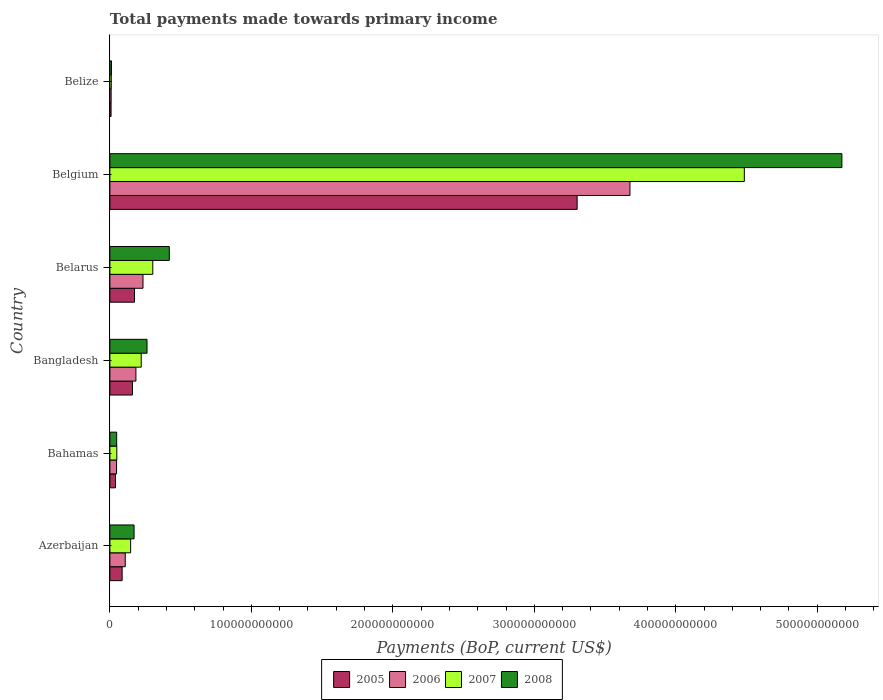Are the number of bars per tick equal to the number of legend labels?
Make the answer very short. Yes. Are the number of bars on each tick of the Y-axis equal?
Provide a succinct answer. Yes. What is the label of the 1st group of bars from the top?
Give a very brief answer. Belize. What is the total payments made towards primary income in 2008 in Belgium?
Your answer should be compact. 5.17e+11. Across all countries, what is the maximum total payments made towards primary income in 2005?
Provide a succinct answer. 3.30e+11. Across all countries, what is the minimum total payments made towards primary income in 2006?
Your response must be concise. 8.85e+08. In which country was the total payments made towards primary income in 2008 minimum?
Make the answer very short. Belize. What is the total total payments made towards primary income in 2005 in the graph?
Keep it short and to the point. 3.77e+11. What is the difference between the total payments made towards primary income in 2006 in Belarus and that in Belgium?
Offer a terse response. -3.44e+11. What is the difference between the total payments made towards primary income in 2008 in Belize and the total payments made towards primary income in 2007 in Belgium?
Give a very brief answer. -4.47e+11. What is the average total payments made towards primary income in 2008 per country?
Your answer should be compact. 1.01e+11. What is the difference between the total payments made towards primary income in 2006 and total payments made towards primary income in 2005 in Bahamas?
Give a very brief answer. 7.72e+08. In how many countries, is the total payments made towards primary income in 2008 greater than 280000000000 US$?
Your response must be concise. 1. What is the ratio of the total payments made towards primary income in 2005 in Azerbaijan to that in Belarus?
Offer a terse response. 0.5. What is the difference between the highest and the second highest total payments made towards primary income in 2007?
Offer a very short reply. 4.18e+11. What is the difference between the highest and the lowest total payments made towards primary income in 2008?
Give a very brief answer. 5.16e+11. In how many countries, is the total payments made towards primary income in 2008 greater than the average total payments made towards primary income in 2008 taken over all countries?
Keep it short and to the point. 1. Is it the case that in every country, the sum of the total payments made towards primary income in 2007 and total payments made towards primary income in 2005 is greater than the sum of total payments made towards primary income in 2008 and total payments made towards primary income in 2006?
Ensure brevity in your answer.  No. What does the 4th bar from the top in Belize represents?
Ensure brevity in your answer.  2005. What does the 4th bar from the bottom in Belarus represents?
Your answer should be compact. 2008. What is the difference between two consecutive major ticks on the X-axis?
Give a very brief answer. 1.00e+11. How are the legend labels stacked?
Offer a terse response. Horizontal. What is the title of the graph?
Your response must be concise. Total payments made towards primary income. Does "2004" appear as one of the legend labels in the graph?
Your response must be concise. No. What is the label or title of the X-axis?
Give a very brief answer. Payments (BoP, current US$). What is the label or title of the Y-axis?
Provide a short and direct response. Country. What is the Payments (BoP, current US$) in 2005 in Azerbaijan?
Offer a terse response. 8.66e+09. What is the Payments (BoP, current US$) in 2006 in Azerbaijan?
Provide a short and direct response. 1.09e+1. What is the Payments (BoP, current US$) of 2007 in Azerbaijan?
Keep it short and to the point. 1.47e+1. What is the Payments (BoP, current US$) in 2008 in Azerbaijan?
Give a very brief answer. 1.71e+1. What is the Payments (BoP, current US$) in 2005 in Bahamas?
Make the answer very short. 3.94e+09. What is the Payments (BoP, current US$) of 2006 in Bahamas?
Your answer should be compact. 4.71e+09. What is the Payments (BoP, current US$) in 2007 in Bahamas?
Offer a very short reply. 4.89e+09. What is the Payments (BoP, current US$) in 2008 in Bahamas?
Make the answer very short. 4.80e+09. What is the Payments (BoP, current US$) of 2005 in Bangladesh?
Ensure brevity in your answer.  1.60e+1. What is the Payments (BoP, current US$) in 2006 in Bangladesh?
Ensure brevity in your answer.  1.84e+1. What is the Payments (BoP, current US$) of 2007 in Bangladesh?
Ensure brevity in your answer.  2.22e+1. What is the Payments (BoP, current US$) of 2008 in Bangladesh?
Provide a succinct answer. 2.62e+1. What is the Payments (BoP, current US$) in 2005 in Belarus?
Provide a short and direct response. 1.74e+1. What is the Payments (BoP, current US$) of 2006 in Belarus?
Your response must be concise. 2.34e+1. What is the Payments (BoP, current US$) of 2007 in Belarus?
Give a very brief answer. 3.03e+1. What is the Payments (BoP, current US$) in 2008 in Belarus?
Your answer should be compact. 4.20e+1. What is the Payments (BoP, current US$) in 2005 in Belgium?
Your answer should be compact. 3.30e+11. What is the Payments (BoP, current US$) in 2006 in Belgium?
Provide a short and direct response. 3.68e+11. What is the Payments (BoP, current US$) in 2007 in Belgium?
Your answer should be compact. 4.48e+11. What is the Payments (BoP, current US$) of 2008 in Belgium?
Provide a succinct answer. 5.17e+11. What is the Payments (BoP, current US$) of 2005 in Belize?
Give a very brief answer. 8.24e+08. What is the Payments (BoP, current US$) of 2006 in Belize?
Offer a very short reply. 8.85e+08. What is the Payments (BoP, current US$) in 2007 in Belize?
Your answer should be compact. 9.69e+08. What is the Payments (BoP, current US$) of 2008 in Belize?
Provide a short and direct response. 1.13e+09. Across all countries, what is the maximum Payments (BoP, current US$) of 2005?
Your answer should be compact. 3.30e+11. Across all countries, what is the maximum Payments (BoP, current US$) in 2006?
Ensure brevity in your answer.  3.68e+11. Across all countries, what is the maximum Payments (BoP, current US$) in 2007?
Make the answer very short. 4.48e+11. Across all countries, what is the maximum Payments (BoP, current US$) of 2008?
Your response must be concise. 5.17e+11. Across all countries, what is the minimum Payments (BoP, current US$) of 2005?
Your response must be concise. 8.24e+08. Across all countries, what is the minimum Payments (BoP, current US$) of 2006?
Ensure brevity in your answer.  8.85e+08. Across all countries, what is the minimum Payments (BoP, current US$) of 2007?
Provide a succinct answer. 9.69e+08. Across all countries, what is the minimum Payments (BoP, current US$) in 2008?
Provide a succinct answer. 1.13e+09. What is the total Payments (BoP, current US$) in 2005 in the graph?
Provide a succinct answer. 3.77e+11. What is the total Payments (BoP, current US$) in 2006 in the graph?
Your response must be concise. 4.26e+11. What is the total Payments (BoP, current US$) of 2007 in the graph?
Your answer should be very brief. 5.21e+11. What is the total Payments (BoP, current US$) of 2008 in the graph?
Ensure brevity in your answer.  6.09e+11. What is the difference between the Payments (BoP, current US$) in 2005 in Azerbaijan and that in Bahamas?
Keep it short and to the point. 4.71e+09. What is the difference between the Payments (BoP, current US$) of 2006 in Azerbaijan and that in Bahamas?
Offer a very short reply. 6.14e+09. What is the difference between the Payments (BoP, current US$) in 2007 in Azerbaijan and that in Bahamas?
Make the answer very short. 9.78e+09. What is the difference between the Payments (BoP, current US$) in 2008 in Azerbaijan and that in Bahamas?
Provide a short and direct response. 1.23e+1. What is the difference between the Payments (BoP, current US$) in 2005 in Azerbaijan and that in Bangladesh?
Offer a terse response. -7.31e+09. What is the difference between the Payments (BoP, current US$) of 2006 in Azerbaijan and that in Bangladesh?
Your response must be concise. -7.55e+09. What is the difference between the Payments (BoP, current US$) of 2007 in Azerbaijan and that in Bangladesh?
Give a very brief answer. -7.48e+09. What is the difference between the Payments (BoP, current US$) in 2008 in Azerbaijan and that in Bangladesh?
Keep it short and to the point. -9.17e+09. What is the difference between the Payments (BoP, current US$) in 2005 in Azerbaijan and that in Belarus?
Provide a succinct answer. -8.75e+09. What is the difference between the Payments (BoP, current US$) of 2006 in Azerbaijan and that in Belarus?
Keep it short and to the point. -1.26e+1. What is the difference between the Payments (BoP, current US$) of 2007 in Azerbaijan and that in Belarus?
Offer a very short reply. -1.57e+1. What is the difference between the Payments (BoP, current US$) of 2008 in Azerbaijan and that in Belarus?
Keep it short and to the point. -2.49e+1. What is the difference between the Payments (BoP, current US$) in 2005 in Azerbaijan and that in Belgium?
Make the answer very short. -3.22e+11. What is the difference between the Payments (BoP, current US$) of 2006 in Azerbaijan and that in Belgium?
Ensure brevity in your answer.  -3.57e+11. What is the difference between the Payments (BoP, current US$) of 2007 in Azerbaijan and that in Belgium?
Keep it short and to the point. -4.34e+11. What is the difference between the Payments (BoP, current US$) in 2008 in Azerbaijan and that in Belgium?
Your answer should be very brief. -5.00e+11. What is the difference between the Payments (BoP, current US$) of 2005 in Azerbaijan and that in Belize?
Provide a succinct answer. 7.83e+09. What is the difference between the Payments (BoP, current US$) of 2006 in Azerbaijan and that in Belize?
Provide a succinct answer. 9.97e+09. What is the difference between the Payments (BoP, current US$) of 2007 in Azerbaijan and that in Belize?
Offer a very short reply. 1.37e+1. What is the difference between the Payments (BoP, current US$) in 2008 in Azerbaijan and that in Belize?
Your response must be concise. 1.60e+1. What is the difference between the Payments (BoP, current US$) in 2005 in Bahamas and that in Bangladesh?
Offer a terse response. -1.20e+1. What is the difference between the Payments (BoP, current US$) of 2006 in Bahamas and that in Bangladesh?
Make the answer very short. -1.37e+1. What is the difference between the Payments (BoP, current US$) in 2007 in Bahamas and that in Bangladesh?
Your answer should be compact. -1.73e+1. What is the difference between the Payments (BoP, current US$) in 2008 in Bahamas and that in Bangladesh?
Give a very brief answer. -2.14e+1. What is the difference between the Payments (BoP, current US$) in 2005 in Bahamas and that in Belarus?
Give a very brief answer. -1.35e+1. What is the difference between the Payments (BoP, current US$) in 2006 in Bahamas and that in Belarus?
Give a very brief answer. -1.87e+1. What is the difference between the Payments (BoP, current US$) of 2007 in Bahamas and that in Belarus?
Your answer should be compact. -2.54e+1. What is the difference between the Payments (BoP, current US$) in 2008 in Bahamas and that in Belarus?
Ensure brevity in your answer.  -3.72e+1. What is the difference between the Payments (BoP, current US$) of 2005 in Bahamas and that in Belgium?
Offer a terse response. -3.26e+11. What is the difference between the Payments (BoP, current US$) in 2006 in Bahamas and that in Belgium?
Keep it short and to the point. -3.63e+11. What is the difference between the Payments (BoP, current US$) of 2007 in Bahamas and that in Belgium?
Your response must be concise. -4.44e+11. What is the difference between the Payments (BoP, current US$) of 2008 in Bahamas and that in Belgium?
Offer a terse response. -5.13e+11. What is the difference between the Payments (BoP, current US$) of 2005 in Bahamas and that in Belize?
Provide a succinct answer. 3.12e+09. What is the difference between the Payments (BoP, current US$) in 2006 in Bahamas and that in Belize?
Offer a very short reply. 3.83e+09. What is the difference between the Payments (BoP, current US$) of 2007 in Bahamas and that in Belize?
Give a very brief answer. 3.92e+09. What is the difference between the Payments (BoP, current US$) in 2008 in Bahamas and that in Belize?
Give a very brief answer. 3.67e+09. What is the difference between the Payments (BoP, current US$) of 2005 in Bangladesh and that in Belarus?
Offer a terse response. -1.44e+09. What is the difference between the Payments (BoP, current US$) in 2006 in Bangladesh and that in Belarus?
Your answer should be compact. -5.01e+09. What is the difference between the Payments (BoP, current US$) of 2007 in Bangladesh and that in Belarus?
Your answer should be very brief. -8.18e+09. What is the difference between the Payments (BoP, current US$) in 2008 in Bangladesh and that in Belarus?
Your answer should be compact. -1.58e+1. What is the difference between the Payments (BoP, current US$) of 2005 in Bangladesh and that in Belgium?
Offer a terse response. -3.14e+11. What is the difference between the Payments (BoP, current US$) of 2006 in Bangladesh and that in Belgium?
Give a very brief answer. -3.49e+11. What is the difference between the Payments (BoP, current US$) in 2007 in Bangladesh and that in Belgium?
Provide a short and direct response. -4.26e+11. What is the difference between the Payments (BoP, current US$) of 2008 in Bangladesh and that in Belgium?
Offer a terse response. -4.91e+11. What is the difference between the Payments (BoP, current US$) in 2005 in Bangladesh and that in Belize?
Offer a terse response. 1.51e+1. What is the difference between the Payments (BoP, current US$) in 2006 in Bangladesh and that in Belize?
Keep it short and to the point. 1.75e+1. What is the difference between the Payments (BoP, current US$) in 2007 in Bangladesh and that in Belize?
Offer a very short reply. 2.12e+1. What is the difference between the Payments (BoP, current US$) of 2008 in Bangladesh and that in Belize?
Provide a succinct answer. 2.51e+1. What is the difference between the Payments (BoP, current US$) in 2005 in Belarus and that in Belgium?
Your response must be concise. -3.13e+11. What is the difference between the Payments (BoP, current US$) of 2006 in Belarus and that in Belgium?
Make the answer very short. -3.44e+11. What is the difference between the Payments (BoP, current US$) of 2007 in Belarus and that in Belgium?
Keep it short and to the point. -4.18e+11. What is the difference between the Payments (BoP, current US$) in 2008 in Belarus and that in Belgium?
Keep it short and to the point. -4.75e+11. What is the difference between the Payments (BoP, current US$) of 2005 in Belarus and that in Belize?
Your answer should be compact. 1.66e+1. What is the difference between the Payments (BoP, current US$) in 2006 in Belarus and that in Belize?
Your response must be concise. 2.25e+1. What is the difference between the Payments (BoP, current US$) of 2007 in Belarus and that in Belize?
Keep it short and to the point. 2.94e+1. What is the difference between the Payments (BoP, current US$) of 2008 in Belarus and that in Belize?
Your answer should be very brief. 4.09e+1. What is the difference between the Payments (BoP, current US$) in 2005 in Belgium and that in Belize?
Your answer should be compact. 3.29e+11. What is the difference between the Payments (BoP, current US$) of 2006 in Belgium and that in Belize?
Give a very brief answer. 3.67e+11. What is the difference between the Payments (BoP, current US$) in 2007 in Belgium and that in Belize?
Provide a succinct answer. 4.47e+11. What is the difference between the Payments (BoP, current US$) of 2008 in Belgium and that in Belize?
Provide a short and direct response. 5.16e+11. What is the difference between the Payments (BoP, current US$) of 2005 in Azerbaijan and the Payments (BoP, current US$) of 2006 in Bahamas?
Give a very brief answer. 3.94e+09. What is the difference between the Payments (BoP, current US$) in 2005 in Azerbaijan and the Payments (BoP, current US$) in 2007 in Bahamas?
Your response must be concise. 3.77e+09. What is the difference between the Payments (BoP, current US$) in 2005 in Azerbaijan and the Payments (BoP, current US$) in 2008 in Bahamas?
Offer a terse response. 3.86e+09. What is the difference between the Payments (BoP, current US$) of 2006 in Azerbaijan and the Payments (BoP, current US$) of 2007 in Bahamas?
Keep it short and to the point. 5.96e+09. What is the difference between the Payments (BoP, current US$) in 2006 in Azerbaijan and the Payments (BoP, current US$) in 2008 in Bahamas?
Your answer should be very brief. 6.05e+09. What is the difference between the Payments (BoP, current US$) in 2007 in Azerbaijan and the Payments (BoP, current US$) in 2008 in Bahamas?
Provide a short and direct response. 9.87e+09. What is the difference between the Payments (BoP, current US$) of 2005 in Azerbaijan and the Payments (BoP, current US$) of 2006 in Bangladesh?
Offer a very short reply. -9.74e+09. What is the difference between the Payments (BoP, current US$) in 2005 in Azerbaijan and the Payments (BoP, current US$) in 2007 in Bangladesh?
Offer a terse response. -1.35e+1. What is the difference between the Payments (BoP, current US$) in 2005 in Azerbaijan and the Payments (BoP, current US$) in 2008 in Bangladesh?
Offer a terse response. -1.76e+1. What is the difference between the Payments (BoP, current US$) of 2006 in Azerbaijan and the Payments (BoP, current US$) of 2007 in Bangladesh?
Provide a short and direct response. -1.13e+1. What is the difference between the Payments (BoP, current US$) in 2006 in Azerbaijan and the Payments (BoP, current US$) in 2008 in Bangladesh?
Your answer should be compact. -1.54e+1. What is the difference between the Payments (BoP, current US$) of 2007 in Azerbaijan and the Payments (BoP, current US$) of 2008 in Bangladesh?
Give a very brief answer. -1.16e+1. What is the difference between the Payments (BoP, current US$) in 2005 in Azerbaijan and the Payments (BoP, current US$) in 2006 in Belarus?
Make the answer very short. -1.47e+1. What is the difference between the Payments (BoP, current US$) in 2005 in Azerbaijan and the Payments (BoP, current US$) in 2007 in Belarus?
Make the answer very short. -2.17e+1. What is the difference between the Payments (BoP, current US$) in 2005 in Azerbaijan and the Payments (BoP, current US$) in 2008 in Belarus?
Give a very brief answer. -3.33e+1. What is the difference between the Payments (BoP, current US$) of 2006 in Azerbaijan and the Payments (BoP, current US$) of 2007 in Belarus?
Give a very brief answer. -1.95e+1. What is the difference between the Payments (BoP, current US$) of 2006 in Azerbaijan and the Payments (BoP, current US$) of 2008 in Belarus?
Make the answer very short. -3.12e+1. What is the difference between the Payments (BoP, current US$) of 2007 in Azerbaijan and the Payments (BoP, current US$) of 2008 in Belarus?
Make the answer very short. -2.73e+1. What is the difference between the Payments (BoP, current US$) of 2005 in Azerbaijan and the Payments (BoP, current US$) of 2006 in Belgium?
Your answer should be compact. -3.59e+11. What is the difference between the Payments (BoP, current US$) of 2005 in Azerbaijan and the Payments (BoP, current US$) of 2007 in Belgium?
Your answer should be compact. -4.40e+11. What is the difference between the Payments (BoP, current US$) in 2005 in Azerbaijan and the Payments (BoP, current US$) in 2008 in Belgium?
Your answer should be very brief. -5.09e+11. What is the difference between the Payments (BoP, current US$) in 2006 in Azerbaijan and the Payments (BoP, current US$) in 2007 in Belgium?
Give a very brief answer. -4.38e+11. What is the difference between the Payments (BoP, current US$) of 2006 in Azerbaijan and the Payments (BoP, current US$) of 2008 in Belgium?
Your answer should be compact. -5.07e+11. What is the difference between the Payments (BoP, current US$) of 2007 in Azerbaijan and the Payments (BoP, current US$) of 2008 in Belgium?
Give a very brief answer. -5.03e+11. What is the difference between the Payments (BoP, current US$) in 2005 in Azerbaijan and the Payments (BoP, current US$) in 2006 in Belize?
Your answer should be very brief. 7.77e+09. What is the difference between the Payments (BoP, current US$) in 2005 in Azerbaijan and the Payments (BoP, current US$) in 2007 in Belize?
Your answer should be very brief. 7.69e+09. What is the difference between the Payments (BoP, current US$) of 2005 in Azerbaijan and the Payments (BoP, current US$) of 2008 in Belize?
Ensure brevity in your answer.  7.53e+09. What is the difference between the Payments (BoP, current US$) of 2006 in Azerbaijan and the Payments (BoP, current US$) of 2007 in Belize?
Your answer should be compact. 9.88e+09. What is the difference between the Payments (BoP, current US$) in 2006 in Azerbaijan and the Payments (BoP, current US$) in 2008 in Belize?
Your response must be concise. 9.72e+09. What is the difference between the Payments (BoP, current US$) in 2007 in Azerbaijan and the Payments (BoP, current US$) in 2008 in Belize?
Give a very brief answer. 1.35e+1. What is the difference between the Payments (BoP, current US$) in 2005 in Bahamas and the Payments (BoP, current US$) in 2006 in Bangladesh?
Ensure brevity in your answer.  -1.45e+1. What is the difference between the Payments (BoP, current US$) of 2005 in Bahamas and the Payments (BoP, current US$) of 2007 in Bangladesh?
Offer a terse response. -1.82e+1. What is the difference between the Payments (BoP, current US$) of 2005 in Bahamas and the Payments (BoP, current US$) of 2008 in Bangladesh?
Make the answer very short. -2.23e+1. What is the difference between the Payments (BoP, current US$) of 2006 in Bahamas and the Payments (BoP, current US$) of 2007 in Bangladesh?
Your answer should be very brief. -1.74e+1. What is the difference between the Payments (BoP, current US$) in 2006 in Bahamas and the Payments (BoP, current US$) in 2008 in Bangladesh?
Your answer should be compact. -2.15e+1. What is the difference between the Payments (BoP, current US$) in 2007 in Bahamas and the Payments (BoP, current US$) in 2008 in Bangladesh?
Make the answer very short. -2.14e+1. What is the difference between the Payments (BoP, current US$) of 2005 in Bahamas and the Payments (BoP, current US$) of 2006 in Belarus?
Make the answer very short. -1.95e+1. What is the difference between the Payments (BoP, current US$) of 2005 in Bahamas and the Payments (BoP, current US$) of 2007 in Belarus?
Offer a terse response. -2.64e+1. What is the difference between the Payments (BoP, current US$) of 2005 in Bahamas and the Payments (BoP, current US$) of 2008 in Belarus?
Your answer should be very brief. -3.81e+1. What is the difference between the Payments (BoP, current US$) in 2006 in Bahamas and the Payments (BoP, current US$) in 2007 in Belarus?
Make the answer very short. -2.56e+1. What is the difference between the Payments (BoP, current US$) in 2006 in Bahamas and the Payments (BoP, current US$) in 2008 in Belarus?
Ensure brevity in your answer.  -3.73e+1. What is the difference between the Payments (BoP, current US$) in 2007 in Bahamas and the Payments (BoP, current US$) in 2008 in Belarus?
Ensure brevity in your answer.  -3.71e+1. What is the difference between the Payments (BoP, current US$) of 2005 in Bahamas and the Payments (BoP, current US$) of 2006 in Belgium?
Give a very brief answer. -3.64e+11. What is the difference between the Payments (BoP, current US$) of 2005 in Bahamas and the Payments (BoP, current US$) of 2007 in Belgium?
Give a very brief answer. -4.45e+11. What is the difference between the Payments (BoP, current US$) of 2005 in Bahamas and the Payments (BoP, current US$) of 2008 in Belgium?
Provide a short and direct response. -5.13e+11. What is the difference between the Payments (BoP, current US$) in 2006 in Bahamas and the Payments (BoP, current US$) in 2007 in Belgium?
Make the answer very short. -4.44e+11. What is the difference between the Payments (BoP, current US$) in 2006 in Bahamas and the Payments (BoP, current US$) in 2008 in Belgium?
Ensure brevity in your answer.  -5.13e+11. What is the difference between the Payments (BoP, current US$) in 2007 in Bahamas and the Payments (BoP, current US$) in 2008 in Belgium?
Ensure brevity in your answer.  -5.13e+11. What is the difference between the Payments (BoP, current US$) of 2005 in Bahamas and the Payments (BoP, current US$) of 2006 in Belize?
Keep it short and to the point. 3.06e+09. What is the difference between the Payments (BoP, current US$) of 2005 in Bahamas and the Payments (BoP, current US$) of 2007 in Belize?
Provide a succinct answer. 2.97e+09. What is the difference between the Payments (BoP, current US$) in 2005 in Bahamas and the Payments (BoP, current US$) in 2008 in Belize?
Your response must be concise. 2.81e+09. What is the difference between the Payments (BoP, current US$) of 2006 in Bahamas and the Payments (BoP, current US$) of 2007 in Belize?
Offer a terse response. 3.75e+09. What is the difference between the Payments (BoP, current US$) in 2006 in Bahamas and the Payments (BoP, current US$) in 2008 in Belize?
Offer a terse response. 3.59e+09. What is the difference between the Payments (BoP, current US$) of 2007 in Bahamas and the Payments (BoP, current US$) of 2008 in Belize?
Provide a succinct answer. 3.76e+09. What is the difference between the Payments (BoP, current US$) of 2005 in Bangladesh and the Payments (BoP, current US$) of 2006 in Belarus?
Your answer should be compact. -7.44e+09. What is the difference between the Payments (BoP, current US$) of 2005 in Bangladesh and the Payments (BoP, current US$) of 2007 in Belarus?
Keep it short and to the point. -1.44e+1. What is the difference between the Payments (BoP, current US$) in 2005 in Bangladesh and the Payments (BoP, current US$) in 2008 in Belarus?
Your answer should be compact. -2.60e+1. What is the difference between the Payments (BoP, current US$) in 2006 in Bangladesh and the Payments (BoP, current US$) in 2007 in Belarus?
Provide a short and direct response. -1.19e+1. What is the difference between the Payments (BoP, current US$) in 2006 in Bangladesh and the Payments (BoP, current US$) in 2008 in Belarus?
Provide a short and direct response. -2.36e+1. What is the difference between the Payments (BoP, current US$) of 2007 in Bangladesh and the Payments (BoP, current US$) of 2008 in Belarus?
Make the answer very short. -1.99e+1. What is the difference between the Payments (BoP, current US$) of 2005 in Bangladesh and the Payments (BoP, current US$) of 2006 in Belgium?
Offer a terse response. -3.52e+11. What is the difference between the Payments (BoP, current US$) in 2005 in Bangladesh and the Payments (BoP, current US$) in 2007 in Belgium?
Provide a short and direct response. -4.32e+11. What is the difference between the Payments (BoP, current US$) in 2005 in Bangladesh and the Payments (BoP, current US$) in 2008 in Belgium?
Offer a terse response. -5.01e+11. What is the difference between the Payments (BoP, current US$) of 2006 in Bangladesh and the Payments (BoP, current US$) of 2007 in Belgium?
Offer a very short reply. -4.30e+11. What is the difference between the Payments (BoP, current US$) of 2006 in Bangladesh and the Payments (BoP, current US$) of 2008 in Belgium?
Provide a succinct answer. -4.99e+11. What is the difference between the Payments (BoP, current US$) of 2007 in Bangladesh and the Payments (BoP, current US$) of 2008 in Belgium?
Keep it short and to the point. -4.95e+11. What is the difference between the Payments (BoP, current US$) of 2005 in Bangladesh and the Payments (BoP, current US$) of 2006 in Belize?
Ensure brevity in your answer.  1.51e+1. What is the difference between the Payments (BoP, current US$) of 2005 in Bangladesh and the Payments (BoP, current US$) of 2007 in Belize?
Offer a very short reply. 1.50e+1. What is the difference between the Payments (BoP, current US$) in 2005 in Bangladesh and the Payments (BoP, current US$) in 2008 in Belize?
Offer a terse response. 1.48e+1. What is the difference between the Payments (BoP, current US$) in 2006 in Bangladesh and the Payments (BoP, current US$) in 2007 in Belize?
Keep it short and to the point. 1.74e+1. What is the difference between the Payments (BoP, current US$) of 2006 in Bangladesh and the Payments (BoP, current US$) of 2008 in Belize?
Provide a succinct answer. 1.73e+1. What is the difference between the Payments (BoP, current US$) of 2007 in Bangladesh and the Payments (BoP, current US$) of 2008 in Belize?
Provide a short and direct response. 2.10e+1. What is the difference between the Payments (BoP, current US$) of 2005 in Belarus and the Payments (BoP, current US$) of 2006 in Belgium?
Give a very brief answer. -3.50e+11. What is the difference between the Payments (BoP, current US$) of 2005 in Belarus and the Payments (BoP, current US$) of 2007 in Belgium?
Your answer should be very brief. -4.31e+11. What is the difference between the Payments (BoP, current US$) of 2005 in Belarus and the Payments (BoP, current US$) of 2008 in Belgium?
Offer a very short reply. -5.00e+11. What is the difference between the Payments (BoP, current US$) of 2006 in Belarus and the Payments (BoP, current US$) of 2007 in Belgium?
Your answer should be compact. -4.25e+11. What is the difference between the Payments (BoP, current US$) in 2006 in Belarus and the Payments (BoP, current US$) in 2008 in Belgium?
Offer a terse response. -4.94e+11. What is the difference between the Payments (BoP, current US$) of 2007 in Belarus and the Payments (BoP, current US$) of 2008 in Belgium?
Give a very brief answer. -4.87e+11. What is the difference between the Payments (BoP, current US$) of 2005 in Belarus and the Payments (BoP, current US$) of 2006 in Belize?
Your answer should be very brief. 1.65e+1. What is the difference between the Payments (BoP, current US$) in 2005 in Belarus and the Payments (BoP, current US$) in 2007 in Belize?
Give a very brief answer. 1.64e+1. What is the difference between the Payments (BoP, current US$) of 2005 in Belarus and the Payments (BoP, current US$) of 2008 in Belize?
Ensure brevity in your answer.  1.63e+1. What is the difference between the Payments (BoP, current US$) of 2006 in Belarus and the Payments (BoP, current US$) of 2007 in Belize?
Keep it short and to the point. 2.24e+1. What is the difference between the Payments (BoP, current US$) in 2006 in Belarus and the Payments (BoP, current US$) in 2008 in Belize?
Keep it short and to the point. 2.23e+1. What is the difference between the Payments (BoP, current US$) in 2007 in Belarus and the Payments (BoP, current US$) in 2008 in Belize?
Make the answer very short. 2.92e+1. What is the difference between the Payments (BoP, current US$) in 2005 in Belgium and the Payments (BoP, current US$) in 2006 in Belize?
Offer a terse response. 3.29e+11. What is the difference between the Payments (BoP, current US$) of 2005 in Belgium and the Payments (BoP, current US$) of 2007 in Belize?
Your response must be concise. 3.29e+11. What is the difference between the Payments (BoP, current US$) of 2005 in Belgium and the Payments (BoP, current US$) of 2008 in Belize?
Your answer should be very brief. 3.29e+11. What is the difference between the Payments (BoP, current US$) in 2006 in Belgium and the Payments (BoP, current US$) in 2007 in Belize?
Your answer should be very brief. 3.67e+11. What is the difference between the Payments (BoP, current US$) in 2006 in Belgium and the Payments (BoP, current US$) in 2008 in Belize?
Your answer should be compact. 3.66e+11. What is the difference between the Payments (BoP, current US$) of 2007 in Belgium and the Payments (BoP, current US$) of 2008 in Belize?
Your answer should be very brief. 4.47e+11. What is the average Payments (BoP, current US$) of 2005 per country?
Keep it short and to the point. 6.28e+1. What is the average Payments (BoP, current US$) of 2006 per country?
Keep it short and to the point. 7.10e+1. What is the average Payments (BoP, current US$) in 2007 per country?
Give a very brief answer. 8.69e+1. What is the average Payments (BoP, current US$) of 2008 per country?
Offer a very short reply. 1.01e+11. What is the difference between the Payments (BoP, current US$) of 2005 and Payments (BoP, current US$) of 2006 in Azerbaijan?
Offer a terse response. -2.20e+09. What is the difference between the Payments (BoP, current US$) in 2005 and Payments (BoP, current US$) in 2007 in Azerbaijan?
Offer a very short reply. -6.01e+09. What is the difference between the Payments (BoP, current US$) in 2005 and Payments (BoP, current US$) in 2008 in Azerbaijan?
Keep it short and to the point. -8.42e+09. What is the difference between the Payments (BoP, current US$) in 2006 and Payments (BoP, current US$) in 2007 in Azerbaijan?
Make the answer very short. -3.82e+09. What is the difference between the Payments (BoP, current US$) of 2006 and Payments (BoP, current US$) of 2008 in Azerbaijan?
Keep it short and to the point. -6.23e+09. What is the difference between the Payments (BoP, current US$) of 2007 and Payments (BoP, current US$) of 2008 in Azerbaijan?
Give a very brief answer. -2.41e+09. What is the difference between the Payments (BoP, current US$) of 2005 and Payments (BoP, current US$) of 2006 in Bahamas?
Make the answer very short. -7.72e+08. What is the difference between the Payments (BoP, current US$) in 2005 and Payments (BoP, current US$) in 2007 in Bahamas?
Ensure brevity in your answer.  -9.46e+08. What is the difference between the Payments (BoP, current US$) in 2005 and Payments (BoP, current US$) in 2008 in Bahamas?
Your response must be concise. -8.58e+08. What is the difference between the Payments (BoP, current US$) in 2006 and Payments (BoP, current US$) in 2007 in Bahamas?
Your response must be concise. -1.75e+08. What is the difference between the Payments (BoP, current US$) in 2006 and Payments (BoP, current US$) in 2008 in Bahamas?
Provide a short and direct response. -8.58e+07. What is the difference between the Payments (BoP, current US$) of 2007 and Payments (BoP, current US$) of 2008 in Bahamas?
Ensure brevity in your answer.  8.88e+07. What is the difference between the Payments (BoP, current US$) of 2005 and Payments (BoP, current US$) of 2006 in Bangladesh?
Your response must be concise. -2.43e+09. What is the difference between the Payments (BoP, current US$) in 2005 and Payments (BoP, current US$) in 2007 in Bangladesh?
Offer a terse response. -6.18e+09. What is the difference between the Payments (BoP, current US$) in 2005 and Payments (BoP, current US$) in 2008 in Bangladesh?
Offer a terse response. -1.03e+1. What is the difference between the Payments (BoP, current US$) of 2006 and Payments (BoP, current US$) of 2007 in Bangladesh?
Your answer should be compact. -3.75e+09. What is the difference between the Payments (BoP, current US$) of 2006 and Payments (BoP, current US$) of 2008 in Bangladesh?
Your answer should be very brief. -7.85e+09. What is the difference between the Payments (BoP, current US$) of 2007 and Payments (BoP, current US$) of 2008 in Bangladesh?
Your answer should be compact. -4.10e+09. What is the difference between the Payments (BoP, current US$) of 2005 and Payments (BoP, current US$) of 2006 in Belarus?
Your answer should be very brief. -6.00e+09. What is the difference between the Payments (BoP, current US$) of 2005 and Payments (BoP, current US$) of 2007 in Belarus?
Offer a very short reply. -1.29e+1. What is the difference between the Payments (BoP, current US$) in 2005 and Payments (BoP, current US$) in 2008 in Belarus?
Your answer should be compact. -2.46e+1. What is the difference between the Payments (BoP, current US$) in 2006 and Payments (BoP, current US$) in 2007 in Belarus?
Your answer should be compact. -6.92e+09. What is the difference between the Payments (BoP, current US$) of 2006 and Payments (BoP, current US$) of 2008 in Belarus?
Make the answer very short. -1.86e+1. What is the difference between the Payments (BoP, current US$) in 2007 and Payments (BoP, current US$) in 2008 in Belarus?
Ensure brevity in your answer.  -1.17e+1. What is the difference between the Payments (BoP, current US$) of 2005 and Payments (BoP, current US$) of 2006 in Belgium?
Offer a very short reply. -3.73e+1. What is the difference between the Payments (BoP, current US$) in 2005 and Payments (BoP, current US$) in 2007 in Belgium?
Make the answer very short. -1.18e+11. What is the difference between the Payments (BoP, current US$) in 2005 and Payments (BoP, current US$) in 2008 in Belgium?
Give a very brief answer. -1.87e+11. What is the difference between the Payments (BoP, current US$) in 2006 and Payments (BoP, current US$) in 2007 in Belgium?
Make the answer very short. -8.08e+1. What is the difference between the Payments (BoP, current US$) of 2006 and Payments (BoP, current US$) of 2008 in Belgium?
Provide a short and direct response. -1.50e+11. What is the difference between the Payments (BoP, current US$) of 2007 and Payments (BoP, current US$) of 2008 in Belgium?
Ensure brevity in your answer.  -6.90e+1. What is the difference between the Payments (BoP, current US$) in 2005 and Payments (BoP, current US$) in 2006 in Belize?
Your answer should be compact. -6.12e+07. What is the difference between the Payments (BoP, current US$) of 2005 and Payments (BoP, current US$) of 2007 in Belize?
Provide a succinct answer. -1.45e+08. What is the difference between the Payments (BoP, current US$) of 2005 and Payments (BoP, current US$) of 2008 in Belize?
Ensure brevity in your answer.  -3.05e+08. What is the difference between the Payments (BoP, current US$) in 2006 and Payments (BoP, current US$) in 2007 in Belize?
Ensure brevity in your answer.  -8.34e+07. What is the difference between the Payments (BoP, current US$) of 2006 and Payments (BoP, current US$) of 2008 in Belize?
Keep it short and to the point. -2.44e+08. What is the difference between the Payments (BoP, current US$) in 2007 and Payments (BoP, current US$) in 2008 in Belize?
Keep it short and to the point. -1.60e+08. What is the ratio of the Payments (BoP, current US$) of 2005 in Azerbaijan to that in Bahamas?
Your response must be concise. 2.2. What is the ratio of the Payments (BoP, current US$) in 2006 in Azerbaijan to that in Bahamas?
Your response must be concise. 2.3. What is the ratio of the Payments (BoP, current US$) of 2007 in Azerbaijan to that in Bahamas?
Your answer should be compact. 3. What is the ratio of the Payments (BoP, current US$) of 2008 in Azerbaijan to that in Bahamas?
Ensure brevity in your answer.  3.56. What is the ratio of the Payments (BoP, current US$) of 2005 in Azerbaijan to that in Bangladesh?
Ensure brevity in your answer.  0.54. What is the ratio of the Payments (BoP, current US$) of 2006 in Azerbaijan to that in Bangladesh?
Make the answer very short. 0.59. What is the ratio of the Payments (BoP, current US$) in 2007 in Azerbaijan to that in Bangladesh?
Ensure brevity in your answer.  0.66. What is the ratio of the Payments (BoP, current US$) of 2008 in Azerbaijan to that in Bangladesh?
Your answer should be very brief. 0.65. What is the ratio of the Payments (BoP, current US$) in 2005 in Azerbaijan to that in Belarus?
Ensure brevity in your answer.  0.5. What is the ratio of the Payments (BoP, current US$) in 2006 in Azerbaijan to that in Belarus?
Your answer should be very brief. 0.46. What is the ratio of the Payments (BoP, current US$) of 2007 in Azerbaijan to that in Belarus?
Ensure brevity in your answer.  0.48. What is the ratio of the Payments (BoP, current US$) in 2008 in Azerbaijan to that in Belarus?
Your response must be concise. 0.41. What is the ratio of the Payments (BoP, current US$) of 2005 in Azerbaijan to that in Belgium?
Provide a short and direct response. 0.03. What is the ratio of the Payments (BoP, current US$) of 2006 in Azerbaijan to that in Belgium?
Offer a very short reply. 0.03. What is the ratio of the Payments (BoP, current US$) in 2007 in Azerbaijan to that in Belgium?
Keep it short and to the point. 0.03. What is the ratio of the Payments (BoP, current US$) in 2008 in Azerbaijan to that in Belgium?
Offer a terse response. 0.03. What is the ratio of the Payments (BoP, current US$) of 2005 in Azerbaijan to that in Belize?
Keep it short and to the point. 10.5. What is the ratio of the Payments (BoP, current US$) in 2006 in Azerbaijan to that in Belize?
Make the answer very short. 12.26. What is the ratio of the Payments (BoP, current US$) of 2007 in Azerbaijan to that in Belize?
Make the answer very short. 15.14. What is the ratio of the Payments (BoP, current US$) in 2008 in Azerbaijan to that in Belize?
Your response must be concise. 15.13. What is the ratio of the Payments (BoP, current US$) of 2005 in Bahamas to that in Bangladesh?
Your answer should be compact. 0.25. What is the ratio of the Payments (BoP, current US$) in 2006 in Bahamas to that in Bangladesh?
Make the answer very short. 0.26. What is the ratio of the Payments (BoP, current US$) of 2007 in Bahamas to that in Bangladesh?
Ensure brevity in your answer.  0.22. What is the ratio of the Payments (BoP, current US$) of 2008 in Bahamas to that in Bangladesh?
Your response must be concise. 0.18. What is the ratio of the Payments (BoP, current US$) of 2005 in Bahamas to that in Belarus?
Give a very brief answer. 0.23. What is the ratio of the Payments (BoP, current US$) of 2006 in Bahamas to that in Belarus?
Your answer should be compact. 0.2. What is the ratio of the Payments (BoP, current US$) of 2007 in Bahamas to that in Belarus?
Offer a very short reply. 0.16. What is the ratio of the Payments (BoP, current US$) of 2008 in Bahamas to that in Belarus?
Offer a terse response. 0.11. What is the ratio of the Payments (BoP, current US$) of 2005 in Bahamas to that in Belgium?
Keep it short and to the point. 0.01. What is the ratio of the Payments (BoP, current US$) in 2006 in Bahamas to that in Belgium?
Give a very brief answer. 0.01. What is the ratio of the Payments (BoP, current US$) in 2007 in Bahamas to that in Belgium?
Offer a terse response. 0.01. What is the ratio of the Payments (BoP, current US$) of 2008 in Bahamas to that in Belgium?
Provide a short and direct response. 0.01. What is the ratio of the Payments (BoP, current US$) of 2005 in Bahamas to that in Belize?
Provide a short and direct response. 4.78. What is the ratio of the Payments (BoP, current US$) of 2006 in Bahamas to that in Belize?
Give a very brief answer. 5.32. What is the ratio of the Payments (BoP, current US$) of 2007 in Bahamas to that in Belize?
Offer a very short reply. 5.05. What is the ratio of the Payments (BoP, current US$) of 2008 in Bahamas to that in Belize?
Offer a very short reply. 4.25. What is the ratio of the Payments (BoP, current US$) of 2005 in Bangladesh to that in Belarus?
Provide a short and direct response. 0.92. What is the ratio of the Payments (BoP, current US$) in 2006 in Bangladesh to that in Belarus?
Offer a terse response. 0.79. What is the ratio of the Payments (BoP, current US$) in 2007 in Bangladesh to that in Belarus?
Keep it short and to the point. 0.73. What is the ratio of the Payments (BoP, current US$) of 2008 in Bangladesh to that in Belarus?
Give a very brief answer. 0.62. What is the ratio of the Payments (BoP, current US$) of 2005 in Bangladesh to that in Belgium?
Offer a terse response. 0.05. What is the ratio of the Payments (BoP, current US$) of 2006 in Bangladesh to that in Belgium?
Your answer should be very brief. 0.05. What is the ratio of the Payments (BoP, current US$) in 2007 in Bangladesh to that in Belgium?
Ensure brevity in your answer.  0.05. What is the ratio of the Payments (BoP, current US$) of 2008 in Bangladesh to that in Belgium?
Keep it short and to the point. 0.05. What is the ratio of the Payments (BoP, current US$) in 2005 in Bangladesh to that in Belize?
Your response must be concise. 19.38. What is the ratio of the Payments (BoP, current US$) in 2006 in Bangladesh to that in Belize?
Your response must be concise. 20.78. What is the ratio of the Payments (BoP, current US$) in 2007 in Bangladesh to that in Belize?
Your answer should be very brief. 22.87. What is the ratio of the Payments (BoP, current US$) of 2008 in Bangladesh to that in Belize?
Your response must be concise. 23.25. What is the ratio of the Payments (BoP, current US$) of 2005 in Belarus to that in Belgium?
Your answer should be compact. 0.05. What is the ratio of the Payments (BoP, current US$) of 2006 in Belarus to that in Belgium?
Give a very brief answer. 0.06. What is the ratio of the Payments (BoP, current US$) of 2007 in Belarus to that in Belgium?
Give a very brief answer. 0.07. What is the ratio of the Payments (BoP, current US$) in 2008 in Belarus to that in Belgium?
Provide a short and direct response. 0.08. What is the ratio of the Payments (BoP, current US$) of 2005 in Belarus to that in Belize?
Keep it short and to the point. 21.12. What is the ratio of the Payments (BoP, current US$) of 2006 in Belarus to that in Belize?
Provide a short and direct response. 26.44. What is the ratio of the Payments (BoP, current US$) in 2007 in Belarus to that in Belize?
Make the answer very short. 31.31. What is the ratio of the Payments (BoP, current US$) in 2008 in Belarus to that in Belize?
Provide a short and direct response. 37.21. What is the ratio of the Payments (BoP, current US$) in 2005 in Belgium to that in Belize?
Make the answer very short. 400.72. What is the ratio of the Payments (BoP, current US$) of 2006 in Belgium to that in Belize?
Keep it short and to the point. 415.18. What is the ratio of the Payments (BoP, current US$) in 2007 in Belgium to that in Belize?
Offer a terse response. 462.9. What is the ratio of the Payments (BoP, current US$) in 2008 in Belgium to that in Belize?
Ensure brevity in your answer.  458.33. What is the difference between the highest and the second highest Payments (BoP, current US$) of 2005?
Keep it short and to the point. 3.13e+11. What is the difference between the highest and the second highest Payments (BoP, current US$) of 2006?
Offer a very short reply. 3.44e+11. What is the difference between the highest and the second highest Payments (BoP, current US$) in 2007?
Ensure brevity in your answer.  4.18e+11. What is the difference between the highest and the second highest Payments (BoP, current US$) of 2008?
Your answer should be compact. 4.75e+11. What is the difference between the highest and the lowest Payments (BoP, current US$) in 2005?
Provide a short and direct response. 3.29e+11. What is the difference between the highest and the lowest Payments (BoP, current US$) in 2006?
Offer a terse response. 3.67e+11. What is the difference between the highest and the lowest Payments (BoP, current US$) in 2007?
Make the answer very short. 4.47e+11. What is the difference between the highest and the lowest Payments (BoP, current US$) in 2008?
Your response must be concise. 5.16e+11. 